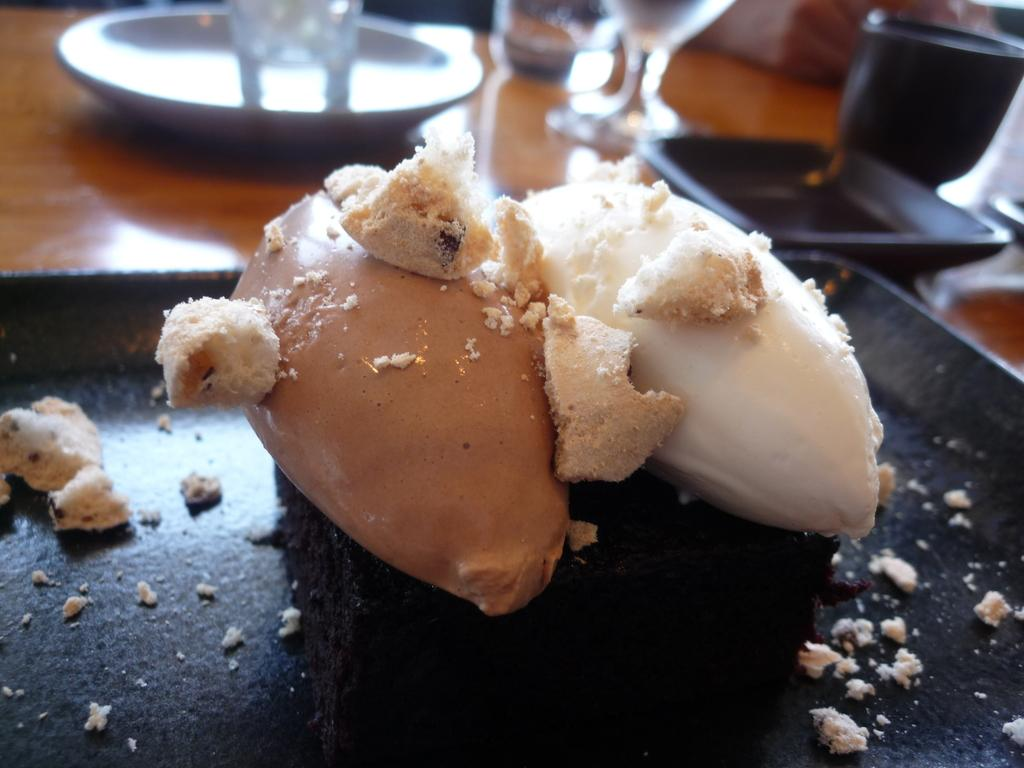What is placed on the table in the image? There is a tray with food items, plates, glasses, and a cup placed on the table. Can you describe the food items on the tray? The provided facts do not specify the type of food items on the tray. How many glasses are visible in the image? There are glasses in the image, but the provided facts do not specify the exact number. What type of container is present for holding liquids? There is a cup in the image for holding liquids. How many cats are sitting on the dock in the image? There are no cats or docks present in the image. Is there a bridge visible in the image? There is no bridge present in the image. 